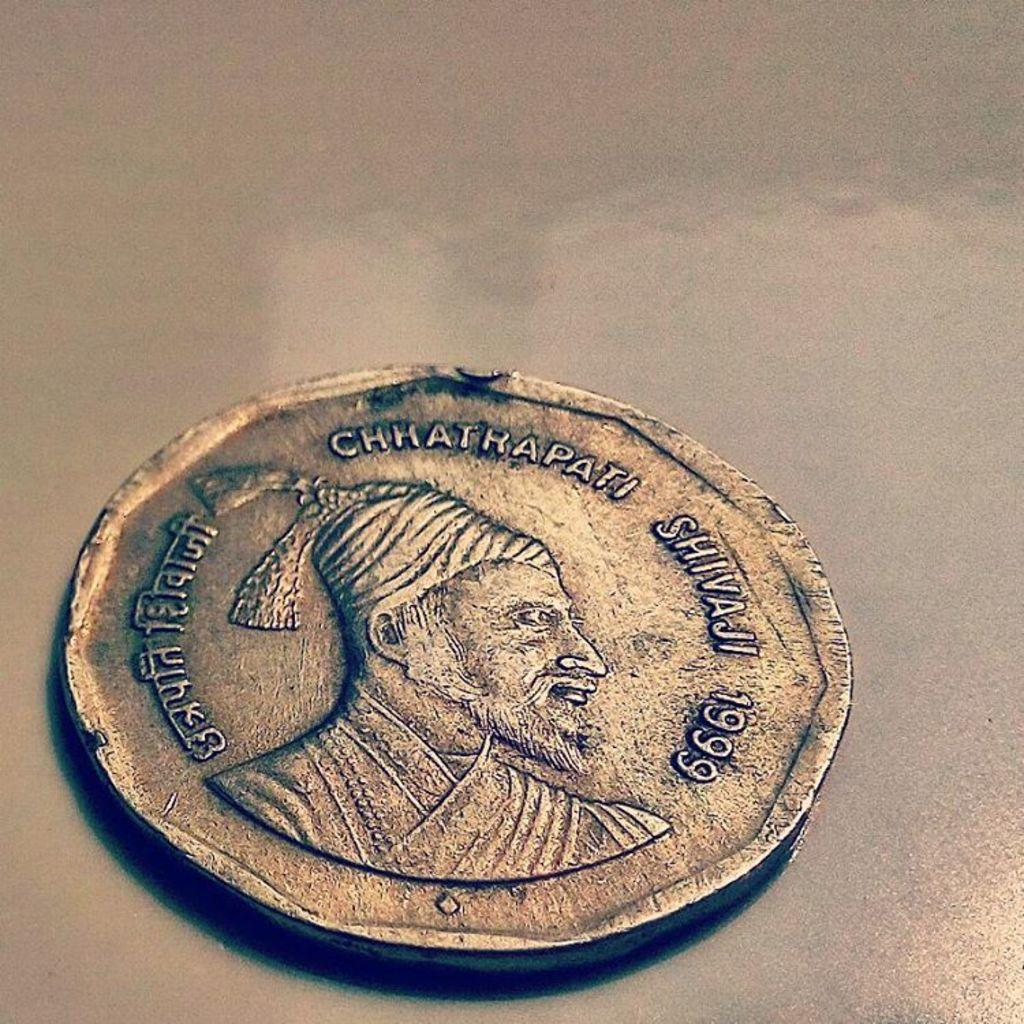<image>
Write a terse but informative summary of the picture. A coin from 1999 with a picture of a man named Chhatrapati Shivaji 